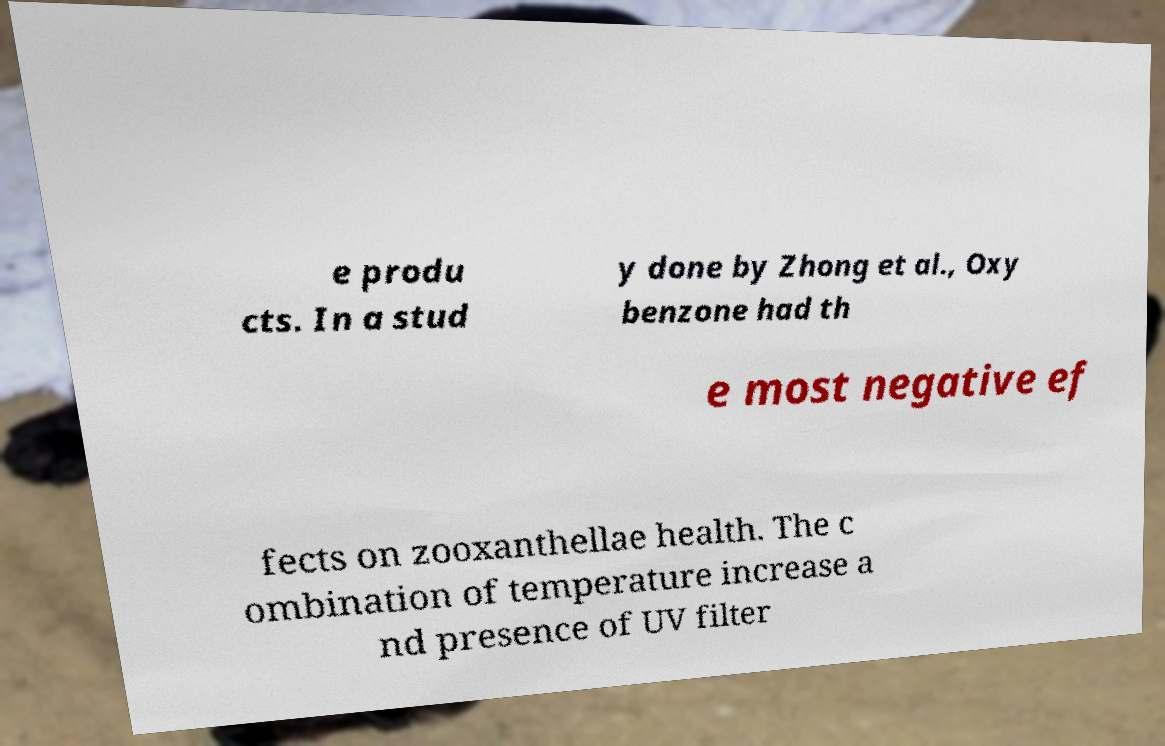I need the written content from this picture converted into text. Can you do that? e produ cts. In a stud y done by Zhong et al., Oxy benzone had th e most negative ef fects on zooxanthellae health. The c ombination of temperature increase a nd presence of UV filter 